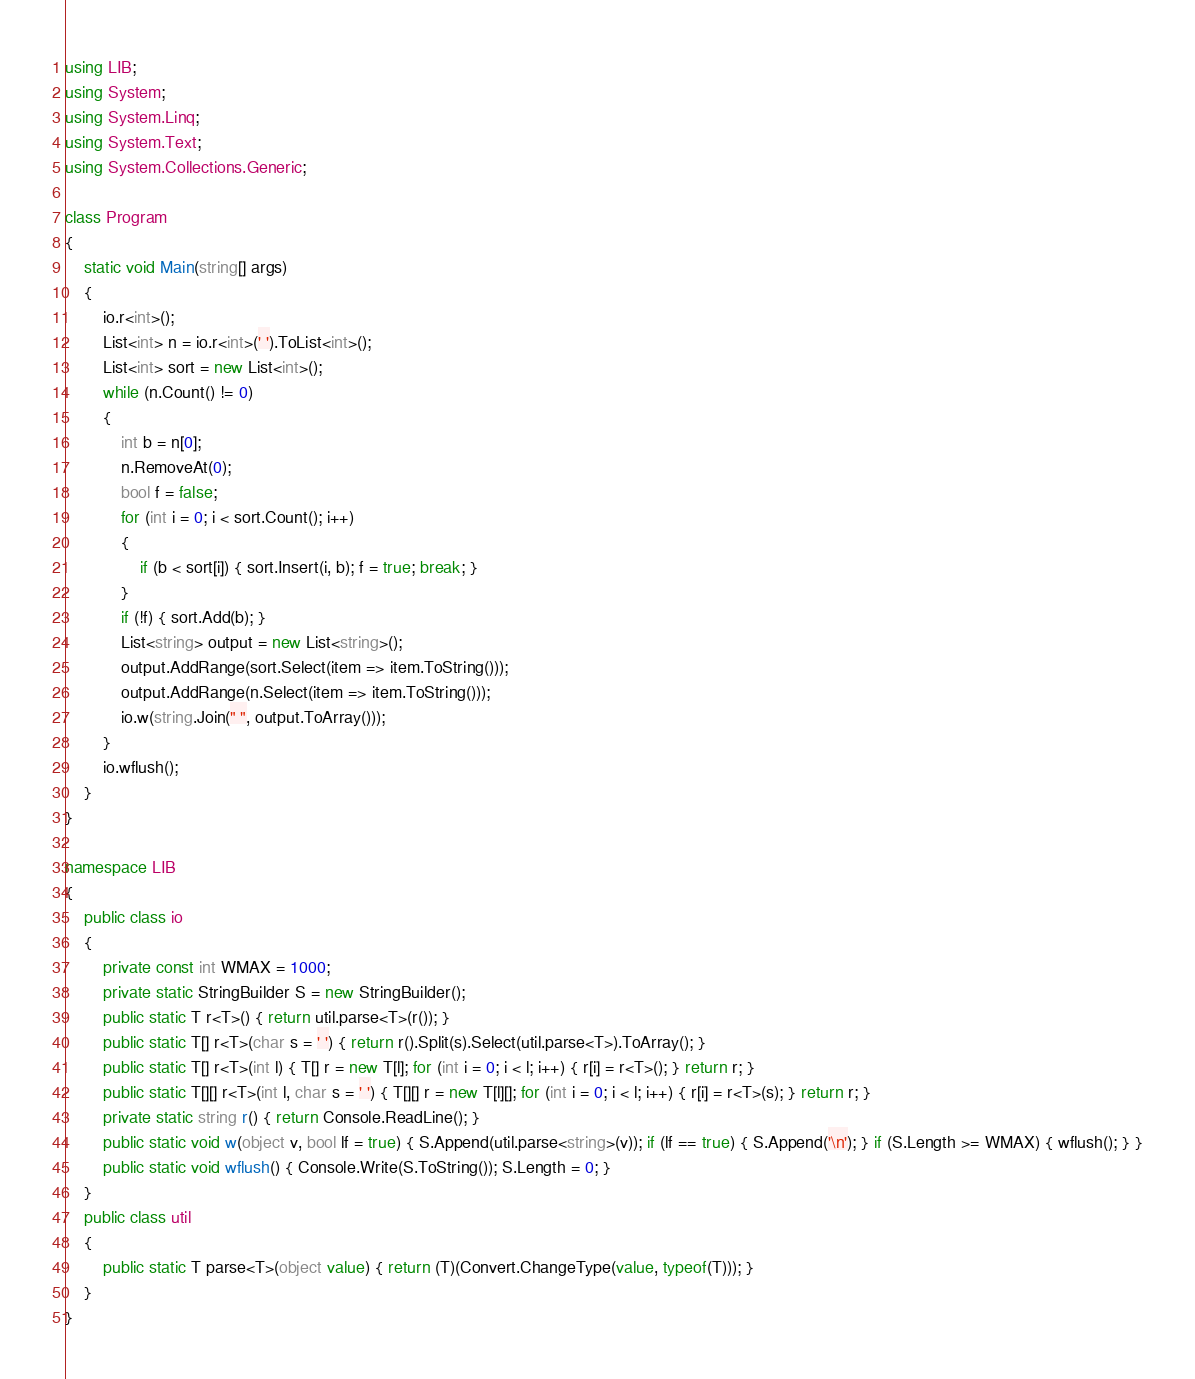<code> <loc_0><loc_0><loc_500><loc_500><_C#_>using LIB;
using System;
using System.Linq;
using System.Text;
using System.Collections.Generic;

class Program
{
    static void Main(string[] args)
    {
        io.r<int>();
        List<int> n = io.r<int>(' ').ToList<int>();
        List<int> sort = new List<int>();
        while (n.Count() != 0)
        {
            int b = n[0];
            n.RemoveAt(0);
            bool f = false;
            for (int i = 0; i < sort.Count(); i++)
            {
                if (b < sort[i]) { sort.Insert(i, b); f = true; break; }
            }
            if (!f) { sort.Add(b); }
            List<string> output = new List<string>();
            output.AddRange(sort.Select(item => item.ToString()));
            output.AddRange(n.Select(item => item.ToString()));
            io.w(string.Join(" ", output.ToArray()));
        }
        io.wflush();
    }
}

namespace LIB
{
    public class io
    {
        private const int WMAX = 1000;
        private static StringBuilder S = new StringBuilder();
        public static T r<T>() { return util.parse<T>(r()); }
        public static T[] r<T>(char s = ' ') { return r().Split(s).Select(util.parse<T>).ToArray(); }
        public static T[] r<T>(int l) { T[] r = new T[l]; for (int i = 0; i < l; i++) { r[i] = r<T>(); } return r; }
        public static T[][] r<T>(int l, char s = ' ') { T[][] r = new T[l][]; for (int i = 0; i < l; i++) { r[i] = r<T>(s); } return r; }
        private static string r() { return Console.ReadLine(); }
        public static void w(object v, bool lf = true) { S.Append(util.parse<string>(v)); if (lf == true) { S.Append('\n'); } if (S.Length >= WMAX) { wflush(); } }
        public static void wflush() { Console.Write(S.ToString()); S.Length = 0; }
    }
    public class util
    {
        public static T parse<T>(object value) { return (T)(Convert.ChangeType(value, typeof(T))); }
    }
}</code> 